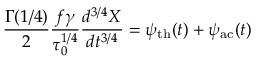<formula> <loc_0><loc_0><loc_500><loc_500>\frac { \Gamma ( 1 / 4 ) } { 2 } \frac { f \gamma } { \tau _ { 0 } ^ { 1 / 4 } } \frac { d ^ { 3 / 4 } X } { d t ^ { 3 / 4 } } = \psi _ { t h } ( t ) + \psi _ { a c } ( t )</formula> 